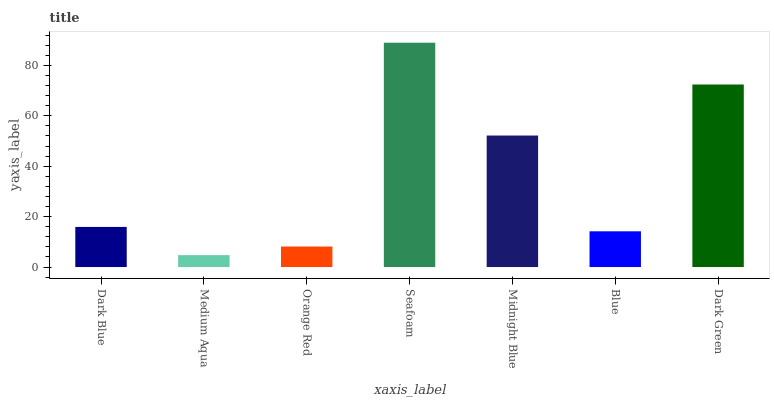Is Medium Aqua the minimum?
Answer yes or no. Yes. Is Seafoam the maximum?
Answer yes or no. Yes. Is Orange Red the minimum?
Answer yes or no. No. Is Orange Red the maximum?
Answer yes or no. No. Is Orange Red greater than Medium Aqua?
Answer yes or no. Yes. Is Medium Aqua less than Orange Red?
Answer yes or no. Yes. Is Medium Aqua greater than Orange Red?
Answer yes or no. No. Is Orange Red less than Medium Aqua?
Answer yes or no. No. Is Dark Blue the high median?
Answer yes or no. Yes. Is Dark Blue the low median?
Answer yes or no. Yes. Is Midnight Blue the high median?
Answer yes or no. No. Is Blue the low median?
Answer yes or no. No. 